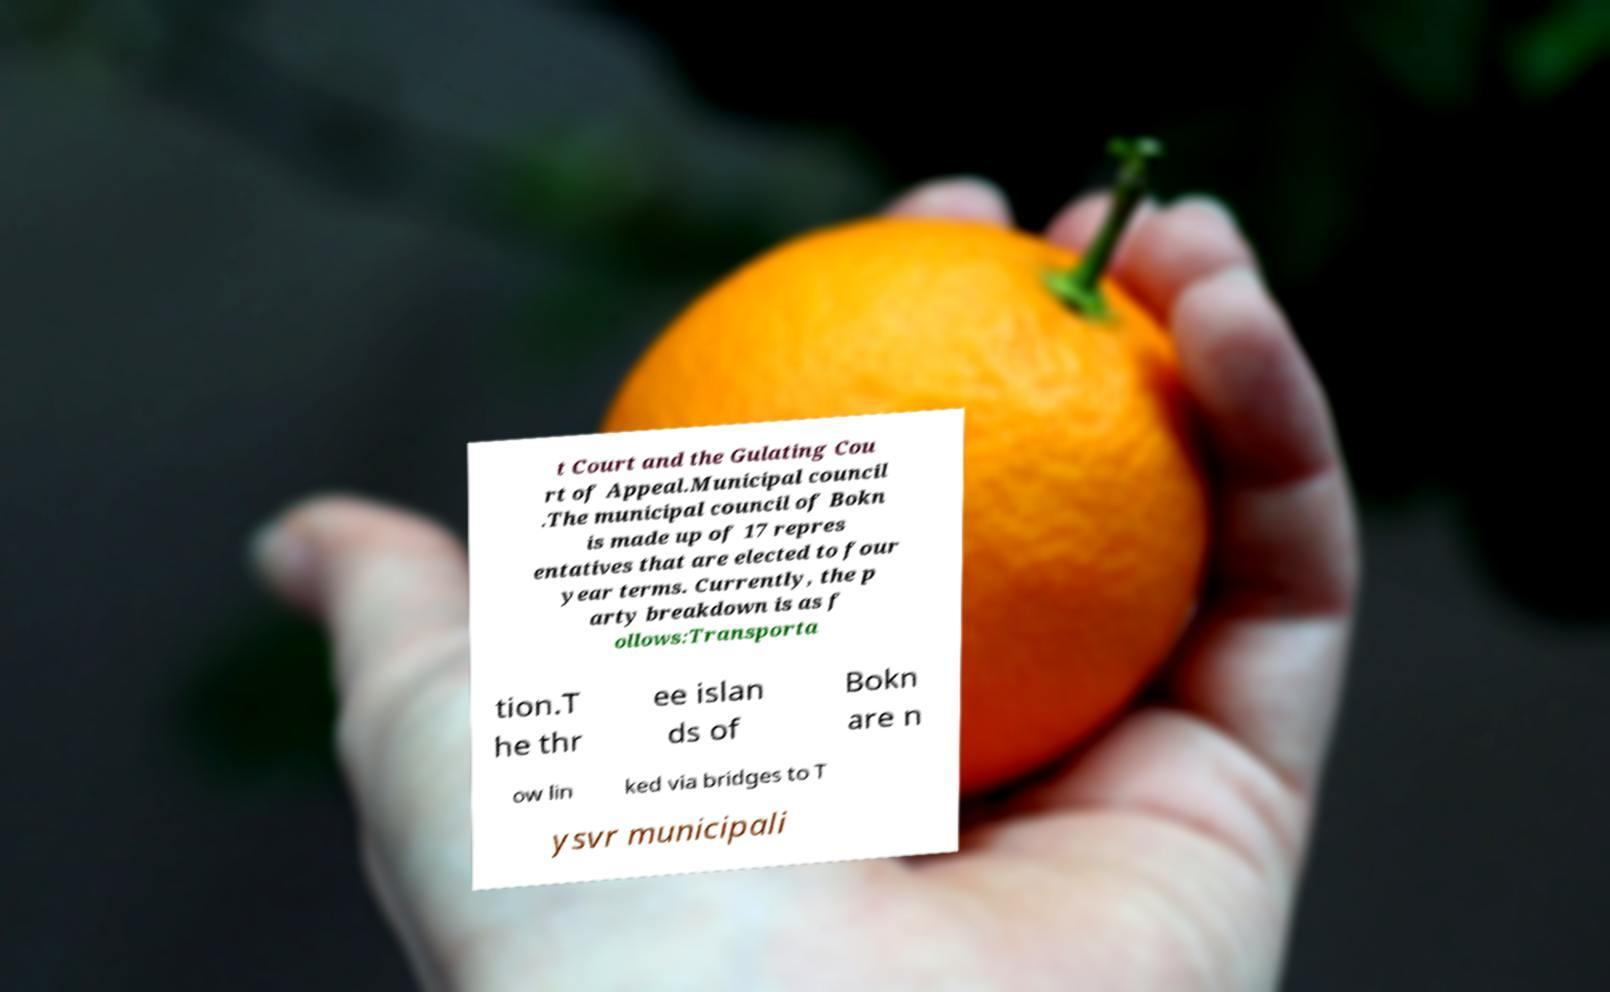Can you accurately transcribe the text from the provided image for me? t Court and the Gulating Cou rt of Appeal.Municipal council .The municipal council of Bokn is made up of 17 repres entatives that are elected to four year terms. Currently, the p arty breakdown is as f ollows:Transporta tion.T he thr ee islan ds of Bokn are n ow lin ked via bridges to T ysvr municipali 